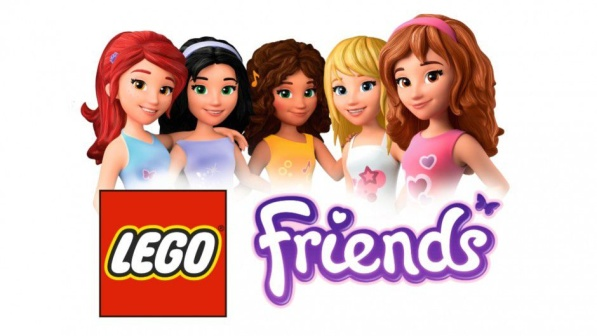Explain the visual content of the image in great detail. The image showcases a vibrant representation of the Lego Friends series with five animated female characters displayed before a bright white background, creating a striking contrast that accentuates their colorful appearance. From the left, the first character adds a touch of sportiness to the group with her ponytailed brown hair, purple sleeveless top, and a contrasting blue skirt. Adjacent to her, the second character exudes a casual aura, her blonde hair flowing freely to match her pink tank top and blue shorts. The central character commands attention with her sleek, bobbed black hair complementing her spirited red top and blue skirt. On her right, another character opts for a chic vibe, her brown hair elegantly tied in a bun atop a green top paired with a blue skirt. Concluding the lineup, the character on the far right channels a playful energy with her blonde ponytail, blue tank top, and light pink skirt. Adding to the scene’s charm are their expressive poses, radiating confidence and camaraderie. Below the characters, the Lego Friends logo is attentively rendered—the brand name 'LEGO' adorns the top in bold white letters set against the iconic red backdrop, while 'Friends' is written below in playful purple cursive, symbolizing the collection's theme of friendship and creativity. This artistic depiction captures not just the look of the characters but also the joyful essence of the Lego Friends line. 